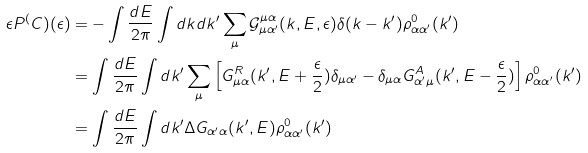Convert formula to latex. <formula><loc_0><loc_0><loc_500><loc_500>\epsilon P ^ { ( } C ) ( \epsilon ) & = - \int \frac { d E } { 2 \pi } \int d k d k ^ { \prime } \sum _ { \mu } \mathcal { G } ^ { \mu \alpha } _ { \mu \alpha ^ { \prime } } ( k , E , \epsilon ) \delta ( k - k ^ { \prime } ) \rho ^ { 0 } _ { \alpha \alpha ^ { \prime } } ( k ^ { \prime } ) \\ & = \int \frac { d E } { 2 \pi } \int d k ^ { \prime } \sum _ { \mu } \left [ G ^ { R } _ { \mu \alpha } ( k ^ { \prime } , E + \frac { \epsilon } { 2 } ) \delta _ { \mu \alpha ^ { \prime } } - \delta _ { \mu \alpha } G ^ { A } _ { \alpha ^ { \prime } \mu } ( k ^ { \prime } , E - \frac { \epsilon } { 2 } ) \right ] \rho ^ { 0 } _ { \alpha \alpha ^ { \prime } } ( k ^ { \prime } ) \\ & = \int \frac { d E } { 2 \pi } \int d k ^ { \prime } \Delta G _ { \alpha ^ { \prime } \alpha } ( k ^ { \prime } , E ) \rho ^ { 0 } _ { \alpha \alpha ^ { \prime } } ( k ^ { \prime } )</formula> 